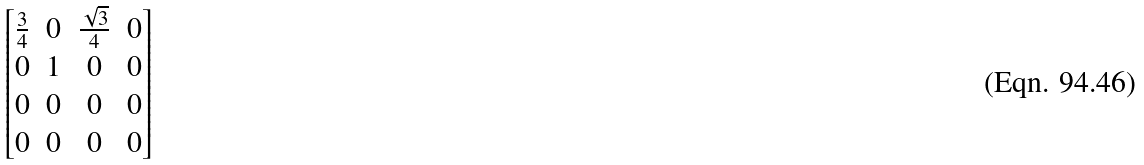Convert formula to latex. <formula><loc_0><loc_0><loc_500><loc_500>\begin{bmatrix} \frac { 3 } { 4 } & 0 & \frac { \sqrt { 3 } } { 4 } & 0 \\ 0 & 1 & 0 & 0 \\ 0 & 0 & 0 & 0 \\ 0 & 0 & 0 & 0 \end{bmatrix}</formula> 